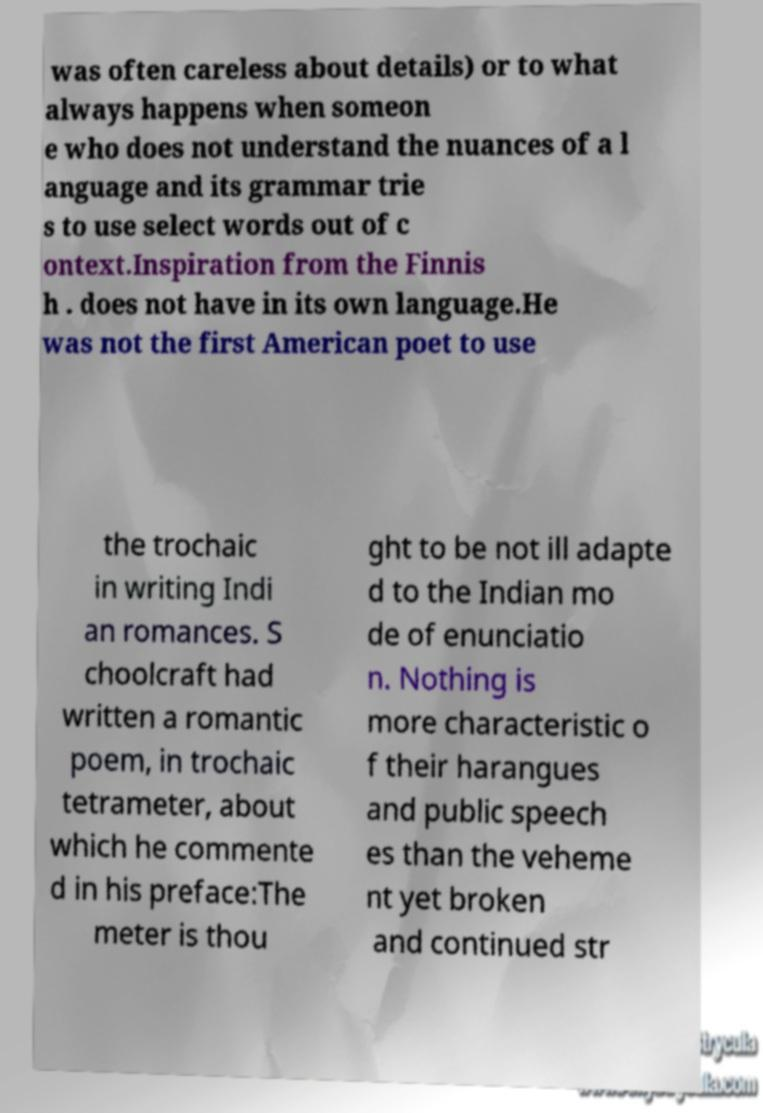Could you assist in decoding the text presented in this image and type it out clearly? was often careless about details) or to what always happens when someon e who does not understand the nuances of a l anguage and its grammar trie s to use select words out of c ontext.Inspiration from the Finnis h . does not have in its own language.He was not the first American poet to use the trochaic in writing Indi an romances. S choolcraft had written a romantic poem, in trochaic tetrameter, about which he commente d in his preface:The meter is thou ght to be not ill adapte d to the Indian mo de of enunciatio n. Nothing is more characteristic o f their harangues and public speech es than the veheme nt yet broken and continued str 